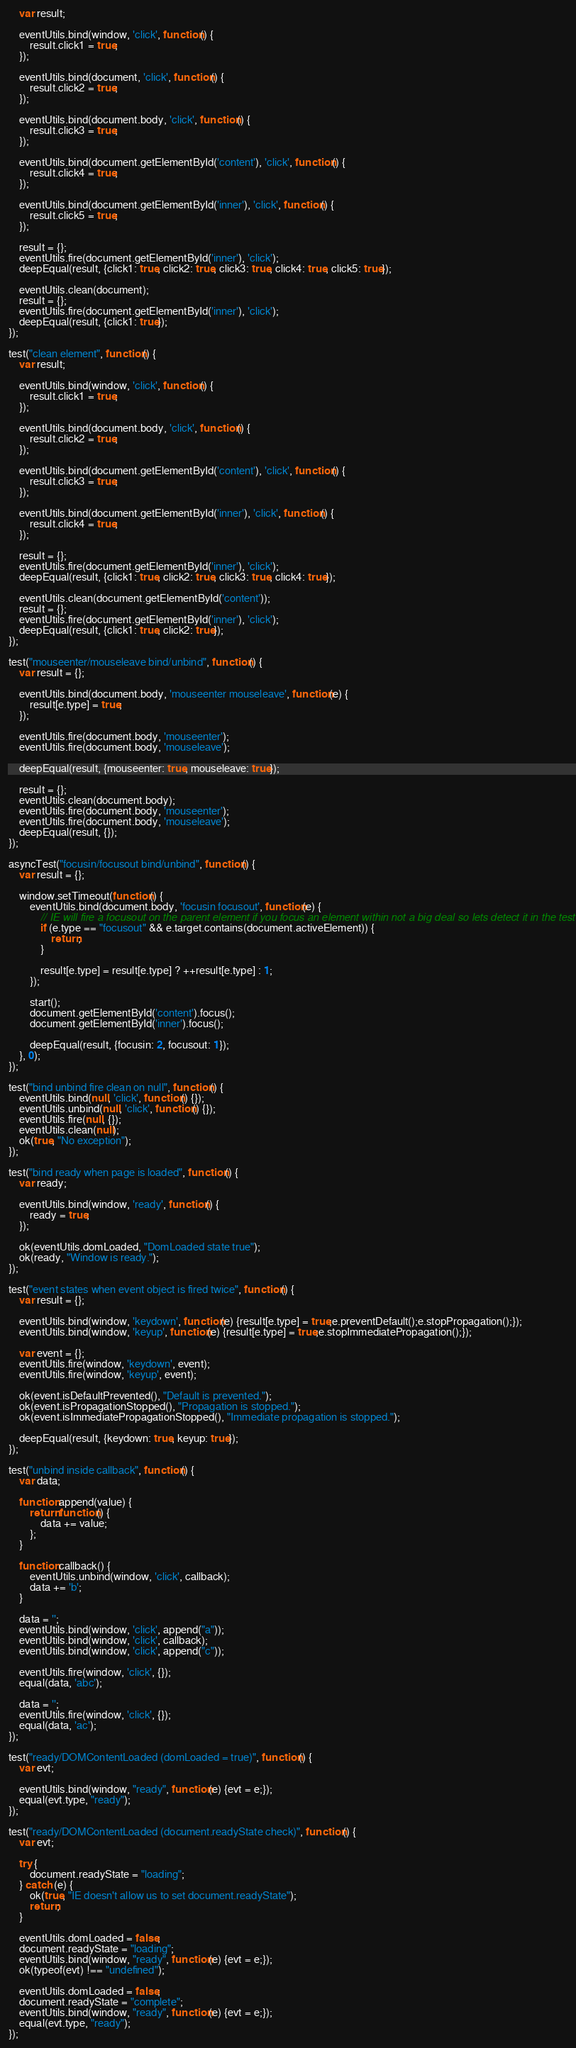Convert code to text. <code><loc_0><loc_0><loc_500><loc_500><_JavaScript_>	var result;

	eventUtils.bind(window, 'click', function() {
		result.click1 = true;
	});

	eventUtils.bind(document, 'click', function() {
		result.click2 = true;
	});

	eventUtils.bind(document.body, 'click', function() {
		result.click3 = true;
	});

	eventUtils.bind(document.getElementById('content'), 'click', function() {
		result.click4 = true;
	});

	eventUtils.bind(document.getElementById('inner'), 'click', function() {
		result.click5 = true;
	});

	result = {};
	eventUtils.fire(document.getElementById('inner'), 'click');
	deepEqual(result, {click1: true, click2: true, click3: true, click4: true, click5: true});

	eventUtils.clean(document);
	result = {};
	eventUtils.fire(document.getElementById('inner'), 'click');
	deepEqual(result, {click1: true});
});

test("clean element", function() {
	var result;

	eventUtils.bind(window, 'click', function() {
		result.click1 = true;
	});

	eventUtils.bind(document.body, 'click', function() {
		result.click2 = true;
	});

	eventUtils.bind(document.getElementById('content'), 'click', function() {
		result.click3 = true;
	});

	eventUtils.bind(document.getElementById('inner'), 'click', function() {
		result.click4 = true;
	});

	result = {};
	eventUtils.fire(document.getElementById('inner'), 'click');
	deepEqual(result, {click1: true, click2: true, click3: true, click4: true});

	eventUtils.clean(document.getElementById('content'));
	result = {};
	eventUtils.fire(document.getElementById('inner'), 'click');
	deepEqual(result, {click1: true, click2: true});
});

test("mouseenter/mouseleave bind/unbind", function() {
	var result = {};

	eventUtils.bind(document.body, 'mouseenter mouseleave', function(e) {
		result[e.type] = true;
	});

	eventUtils.fire(document.body, 'mouseenter');
	eventUtils.fire(document.body, 'mouseleave');

	deepEqual(result, {mouseenter: true, mouseleave: true});

	result = {};
	eventUtils.clean(document.body);
	eventUtils.fire(document.body, 'mouseenter');
	eventUtils.fire(document.body, 'mouseleave');
	deepEqual(result, {});
});

asyncTest("focusin/focusout bind/unbind", function() {
	var result = {};

	window.setTimeout(function() {
		eventUtils.bind(document.body, 'focusin focusout', function(e) {
			// IE will fire a focusout on the parent element if you focus an element within not a big deal so lets detect it in the test
			if (e.type == "focusout" && e.target.contains(document.activeElement)) {
				return;
			}

			result[e.type] = result[e.type] ? ++result[e.type] : 1;
		});

		start();
		document.getElementById('content').focus();
		document.getElementById('inner').focus();

		deepEqual(result, {focusin: 2, focusout: 1});
	}, 0);
});

test("bind unbind fire clean on null", function() {
	eventUtils.bind(null, 'click', function() {});
	eventUtils.unbind(null, 'click', function() {});
	eventUtils.fire(null, {});
	eventUtils.clean(null);
	ok(true, "No exception");
});

test("bind ready when page is loaded", function() {
	var ready;

	eventUtils.bind(window, 'ready', function() {
		ready = true;
	});

	ok(eventUtils.domLoaded, "DomLoaded state true");
	ok(ready, "Window is ready.");
});

test("event states when event object is fired twice", function() {
	var result = {};

	eventUtils.bind(window, 'keydown', function(e) {result[e.type] = true;e.preventDefault();e.stopPropagation();});
	eventUtils.bind(window, 'keyup', function(e) {result[e.type] = true;e.stopImmediatePropagation();});

	var event = {};
	eventUtils.fire(window, 'keydown', event);
	eventUtils.fire(window, 'keyup', event);

	ok(event.isDefaultPrevented(), "Default is prevented.");
	ok(event.isPropagationStopped(), "Propagation is stopped.");
	ok(event.isImmediatePropagationStopped(), "Immediate propagation is stopped.");

	deepEqual(result, {keydown: true, keyup: true});
});

test("unbind inside callback", function() {
	var data;

	function append(value) {
		return function() {
			data += value;
		};
	}

	function callback() {
		eventUtils.unbind(window, 'click', callback);
		data += 'b';
	}

	data = '';
	eventUtils.bind(window, 'click', append("a"));
	eventUtils.bind(window, 'click', callback);
	eventUtils.bind(window, 'click', append("c"));

	eventUtils.fire(window, 'click', {});
	equal(data, 'abc');

	data = '';
	eventUtils.fire(window, 'click', {});
	equal(data, 'ac');
});

test("ready/DOMContentLoaded (domLoaded = true)", function() {
	var evt;

	eventUtils.bind(window, "ready", function(e) {evt = e;});
	equal(evt.type, "ready");
});

test("ready/DOMContentLoaded (document.readyState check)", function() {
	var evt;

	try {
		document.readyState = "loading";
	} catch (e) {
		ok(true, "IE doesn't allow us to set document.readyState");
		return;
	}

	eventUtils.domLoaded = false;
	document.readyState = "loading";
	eventUtils.bind(window, "ready", function(e) {evt = e;});
	ok(typeof(evt) !== "undefined");

	eventUtils.domLoaded = false;
	document.readyState = "complete";
	eventUtils.bind(window, "ready", function(e) {evt = e;});
	equal(evt.type, "ready");
});
</code> 